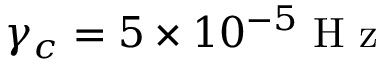Convert formula to latex. <formula><loc_0><loc_0><loc_500><loc_500>\gamma _ { c } = 5 \times 1 0 ^ { - 5 } H z</formula> 